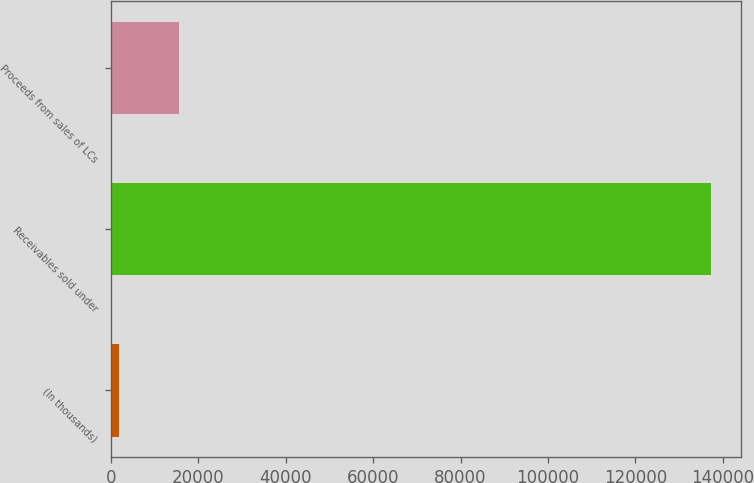<chart> <loc_0><loc_0><loc_500><loc_500><bar_chart><fcel>(In thousands)<fcel>Receivables sold under<fcel>Proceeds from sales of LCs<nl><fcel>2015<fcel>137285<fcel>15542<nl></chart> 